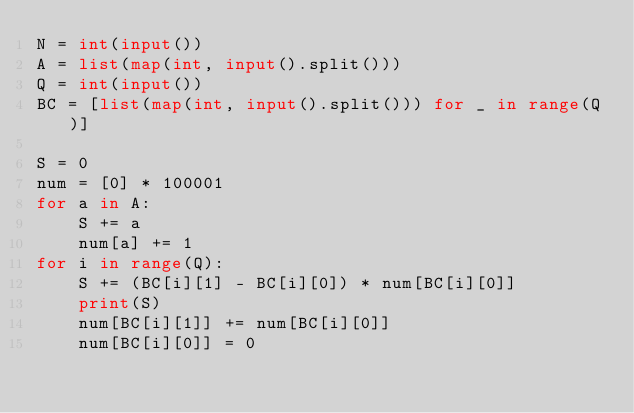<code> <loc_0><loc_0><loc_500><loc_500><_Python_>N = int(input())
A = list(map(int, input().split()))
Q = int(input())
BC = [list(map(int, input().split())) for _ in range(Q)]

S = 0
num = [0] * 100001
for a in A:
    S += a
    num[a] += 1
for i in range(Q):
    S += (BC[i][1] - BC[i][0]) * num[BC[i][0]]
    print(S)
    num[BC[i][1]] += num[BC[i][0]]
    num[BC[i][0]] = 0
</code> 